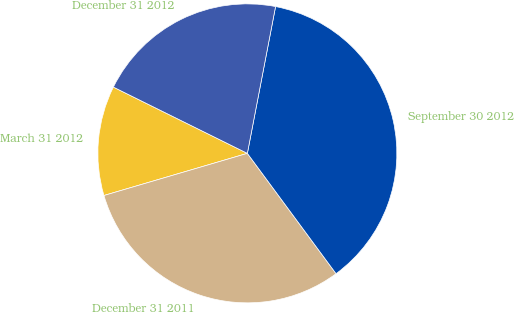Convert chart. <chart><loc_0><loc_0><loc_500><loc_500><pie_chart><fcel>March 31 2012<fcel>December 31 2011<fcel>September 30 2012<fcel>December 31 2012<nl><fcel>11.86%<fcel>30.56%<fcel>36.87%<fcel>20.71%<nl></chart> 